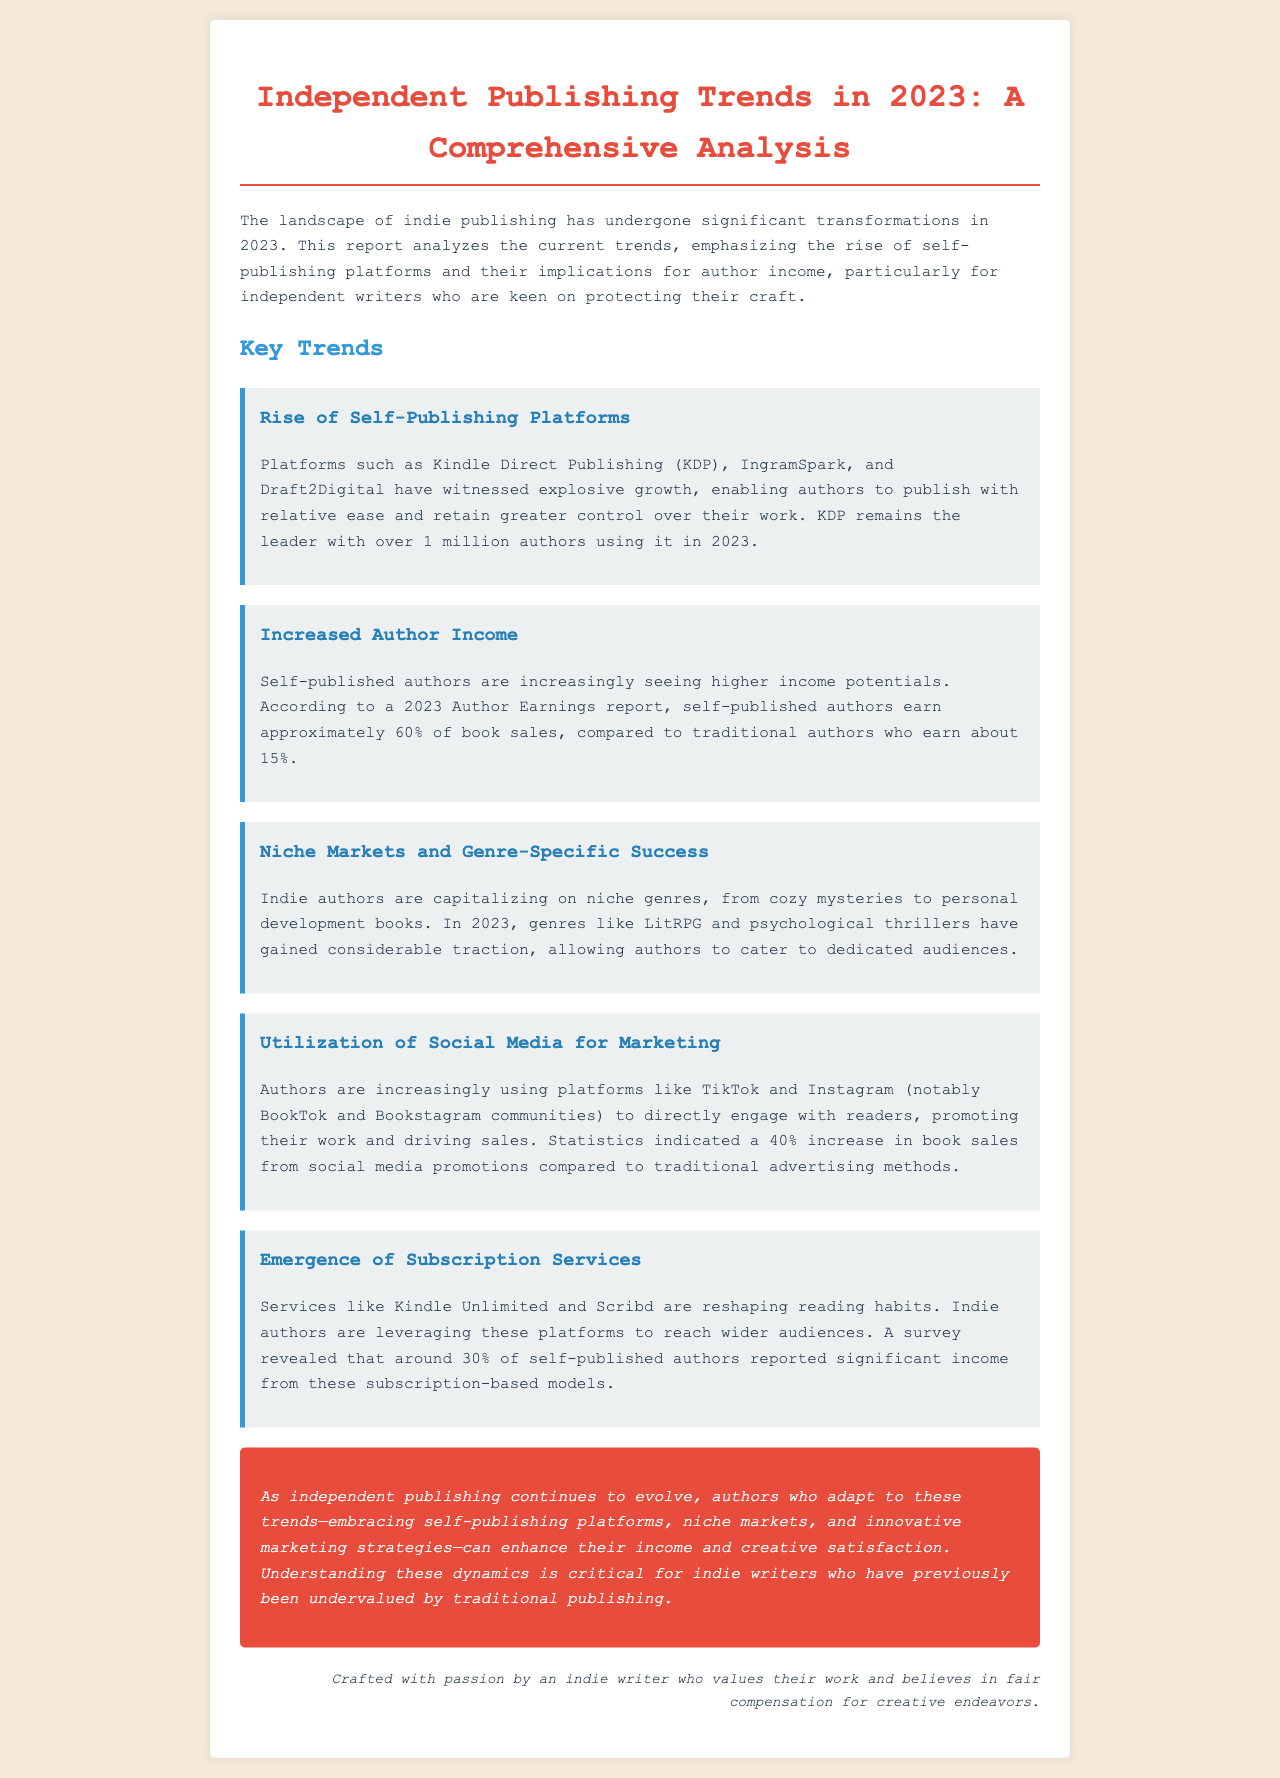What is the primary theme of the report? The document emphasizes the transformations in indie publishing and highlights self-publishing platforms and author income.
Answer: Indie publishing trends How many self-publishing authors does KDP have in 2023? The report states that KDP has over 1 million authors using its platform in 2023.
Answer: Over 1 million What percentage of book sales do self-published authors earn according to the 2023 Author Earnings report? The report mentions that self-published authors earn approximately 60% of book sales.
Answer: 60% What genre saw significant traction in 2023 according to the document? The report identifies LitRPG and psychological thrillers as genres gaining considerable traction.
Answer: LitRPG What social media platform led to a 40% increase in book sales? The document indicates that social media promotions, particularly on TikTok and Instagram, resulted in this sales increase.
Answer: TikTok and Instagram What subscription services are mentioned as reshaping reading habits? The report mentions services like Kindle Unlimited and Scribd in relation to changing reading habits.
Answer: Kindle Unlimited and Scribd What percentage of self-published authors reported significant income from subscription-based models? According to a survey mentioned in the report, about 30% of self-published authors reported significant income from these models.
Answer: 30% What is the conclusion regarding the adaptation of indie authors to trends? The report concludes that authors who adapt to trends can enhance their income and creative satisfaction.
Answer: Enhance income and creative satisfaction 